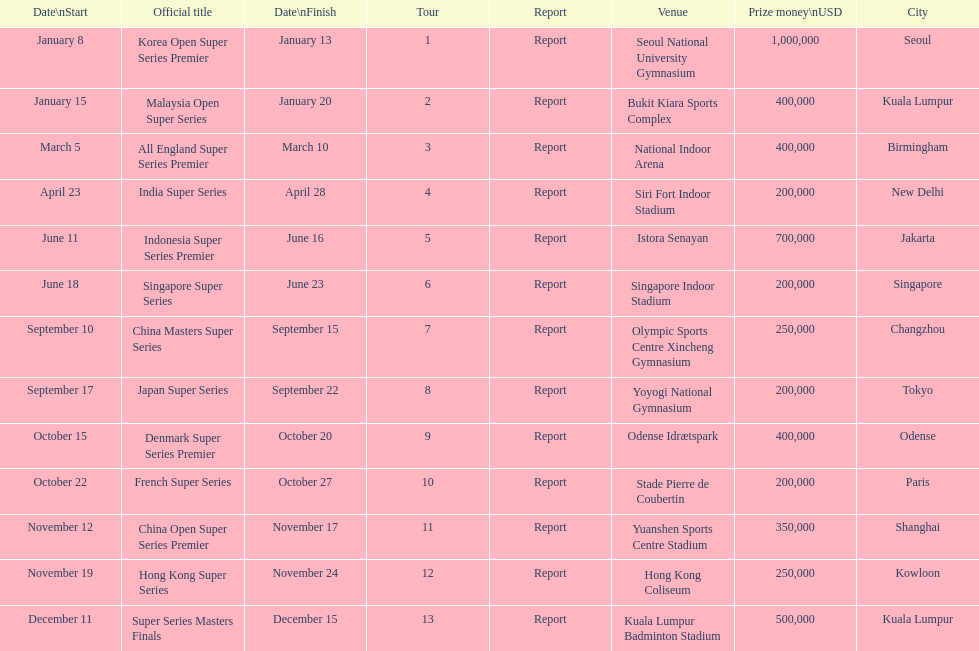Could you parse the entire table? {'header': ['Date\\nStart', 'Official title', 'Date\\nFinish', 'Tour', 'Report', 'Venue', 'Prize money\\nUSD', 'City'], 'rows': [['January 8', 'Korea Open Super Series Premier', 'January 13', '1', 'Report', 'Seoul National University Gymnasium', '1,000,000', 'Seoul'], ['January 15', 'Malaysia Open Super Series', 'January 20', '2', 'Report', 'Bukit Kiara Sports Complex', '400,000', 'Kuala Lumpur'], ['March 5', 'All England Super Series Premier', 'March 10', '3', 'Report', 'National Indoor Arena', '400,000', 'Birmingham'], ['April 23', 'India Super Series', 'April 28', '4', 'Report', 'Siri Fort Indoor Stadium', '200,000', 'New Delhi'], ['June 11', 'Indonesia Super Series Premier', 'June 16', '5', 'Report', 'Istora Senayan', '700,000', 'Jakarta'], ['June 18', 'Singapore Super Series', 'June 23', '6', 'Report', 'Singapore Indoor Stadium', '200,000', 'Singapore'], ['September 10', 'China Masters Super Series', 'September 15', '7', 'Report', 'Olympic Sports Centre Xincheng Gymnasium', '250,000', 'Changzhou'], ['September 17', 'Japan Super Series', 'September 22', '8', 'Report', 'Yoyogi National Gymnasium', '200,000', 'Tokyo'], ['October 15', 'Denmark Super Series Premier', 'October 20', '9', 'Report', 'Odense Idrætspark', '400,000', 'Odense'], ['October 22', 'French Super Series', 'October 27', '10', 'Report', 'Stade Pierre de Coubertin', '200,000', 'Paris'], ['November 12', 'China Open Super Series Premier', 'November 17', '11', 'Report', 'Yuanshen Sports Centre Stadium', '350,000', 'Shanghai'], ['November 19', 'Hong Kong Super Series', 'November 24', '12', 'Report', 'Hong Kong Coliseum', '250,000', 'Kowloon'], ['December 11', 'Super Series Masters Finals', 'December 15', '13', 'Report', 'Kuala Lumpur Badminton Stadium', '500,000', 'Kuala Lumpur']]} How long did the japan super series take? 5 days. 